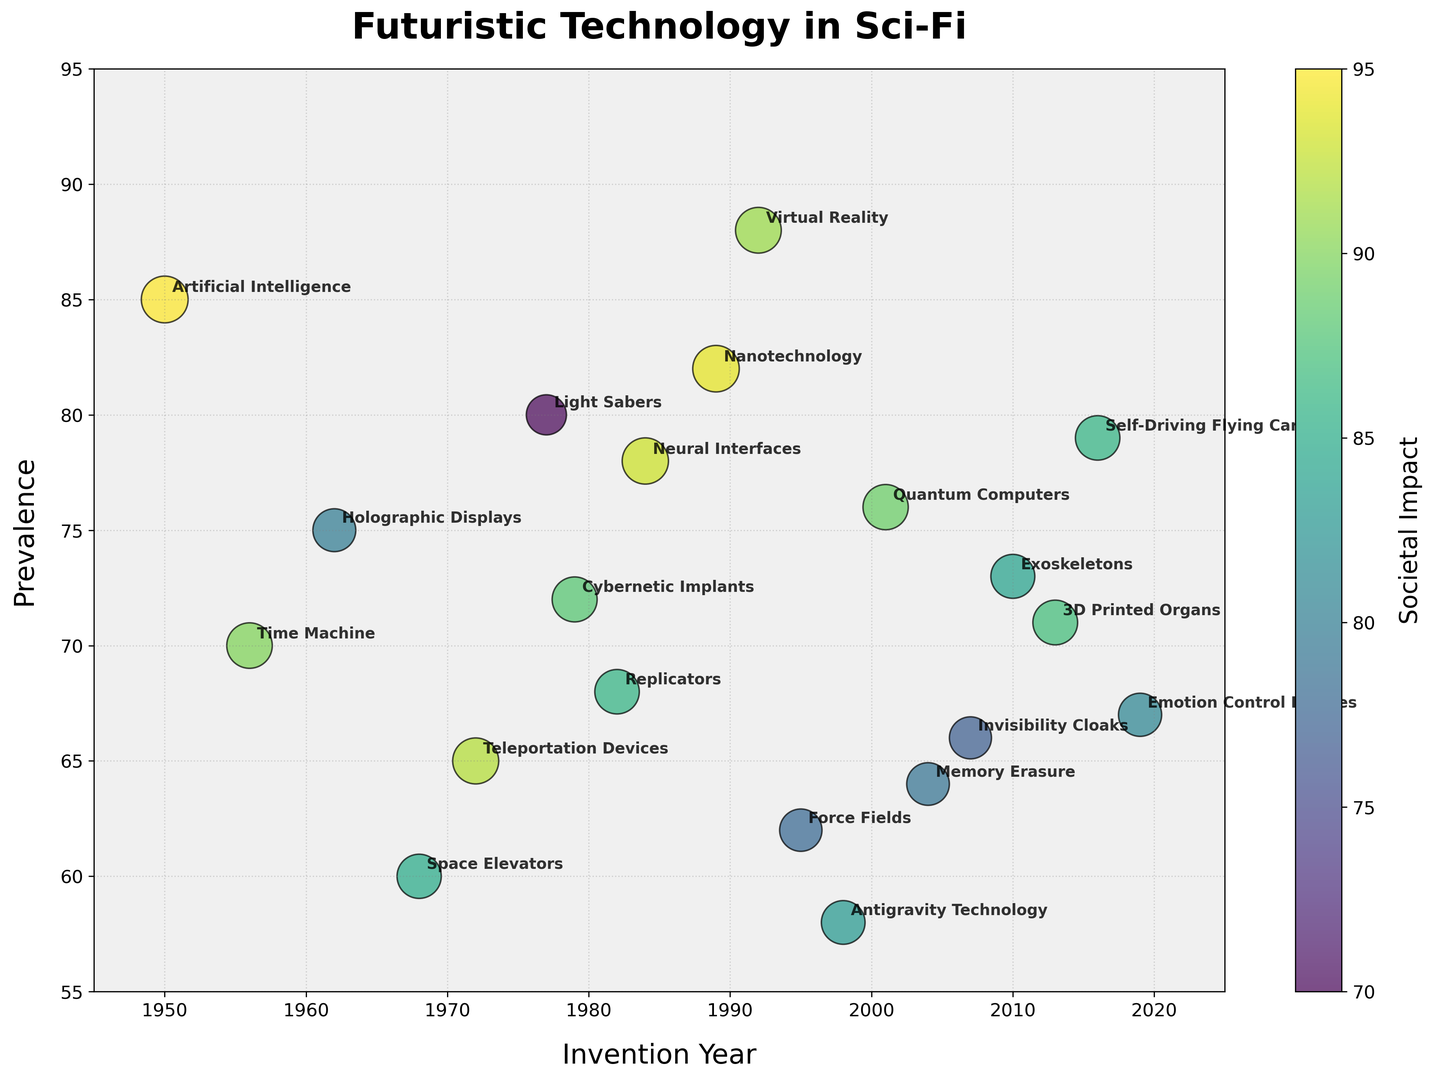Which technology has the highest societal impact? The color bar indicates societal impact, which ranges from 70 to 95. Therefore, the largest bubble or the darkest color will represent the highest societal impact. The bubble for Artificial Intelligence stands out as having the highest societal impact of 95.
Answer: Artificial Intelligence What are the invention years of technologies with a prevalence greater than 80? Look at the bubbles positioned higher in the y-axis (prevalence > 80). The corresponding invention years are for Virtual Reality (1992) and Nanotechnology (1989).
Answer: 1992, 1989 Which technology invented after 2000 has the smallest societal impact, and what is that impact? Check the bubbles beyond the year 2000 and identify the smallest ones. The smallest bubble is for Invisibility Cloaks, with a societal impact of 77.
Answer: Invisibility Cloaks, 77 Which technology has the highest prevalence and in what invention year was it introduced? The technology with the highest prevalence will be at the top of the y-axis. Virtual Reality, which is the highest on the y-axis, was introduced in 1992.
Answer: Virtual Reality, 1992 Which bubble has the largest size among technologies introduced in the 1960s? The technologies from the 1960s are Space Elevators (1968) and Holographic Displays (1962). Space Elevators has a societal impact of 85, while Holographic Displays has 80. Therefore, Space Elevators has the largest bubble among the 1960s technologies.
Answer: Space Elevators Compare the societal impacts of Teleportation Devices and Replicators. Which one has a higher impact? Locate the bubbles for Teleportation Devices (1972) and Replicators (1982). Teleportation Devices has a societal impact of 92, while Replicators has 86. Thus, Teleportation Devices has a higher societal impact.
Answer: Teleportation Devices What is the average prevalence of technologies invented in the 1970s? The 1970s technologies are Teleportation Devices (65), Light Sabers (80), and Cybernetic Implants (72). The average is calculated as (65 + 80 + 72) / 3 = 72.33.
Answer: 72.33 Which technology has the lowest prevalence, and what is its societal impact? Look for the bubble at the bottom-most point on the y-axis. Antigravity Technology has the lowest prevalence of 58, with a societal impact of 83.
Answer: Antigravity Technology, 83 